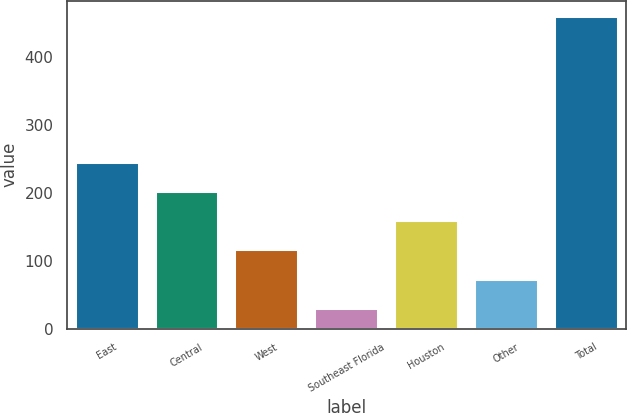Convert chart. <chart><loc_0><loc_0><loc_500><loc_500><bar_chart><fcel>East<fcel>Central<fcel>West<fcel>Southeast Florida<fcel>Houston<fcel>Other<fcel>Total<nl><fcel>245<fcel>202.2<fcel>116.6<fcel>31<fcel>159.4<fcel>73.8<fcel>459<nl></chart> 